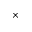<formula> <loc_0><loc_0><loc_500><loc_500>\times</formula> 